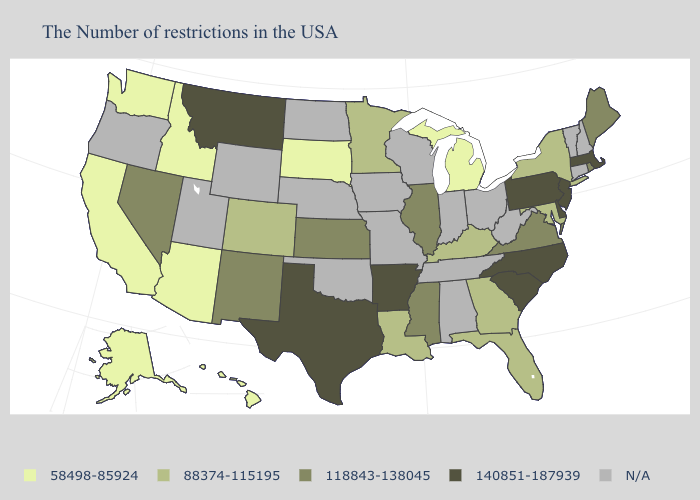What is the lowest value in the USA?
Be succinct. 58498-85924. Name the states that have a value in the range 140851-187939?
Give a very brief answer. Massachusetts, New Jersey, Delaware, Pennsylvania, North Carolina, South Carolina, Arkansas, Texas, Montana. Name the states that have a value in the range N/A?
Keep it brief. New Hampshire, Vermont, Connecticut, West Virginia, Ohio, Indiana, Alabama, Tennessee, Wisconsin, Missouri, Iowa, Nebraska, Oklahoma, North Dakota, Wyoming, Utah, Oregon. What is the value of North Carolina?
Short answer required. 140851-187939. Among the states that border Connecticut , which have the highest value?
Concise answer only. Massachusetts. What is the value of Maine?
Write a very short answer. 118843-138045. What is the value of Illinois?
Be succinct. 118843-138045. What is the lowest value in states that border South Carolina?
Answer briefly. 88374-115195. What is the value of Ohio?
Short answer required. N/A. Name the states that have a value in the range 140851-187939?
Concise answer only. Massachusetts, New Jersey, Delaware, Pennsylvania, North Carolina, South Carolina, Arkansas, Texas, Montana. Does the first symbol in the legend represent the smallest category?
Concise answer only. Yes. Does the map have missing data?
Quick response, please. Yes. Does South Dakota have the lowest value in the MidWest?
Give a very brief answer. Yes. Name the states that have a value in the range N/A?
Write a very short answer. New Hampshire, Vermont, Connecticut, West Virginia, Ohio, Indiana, Alabama, Tennessee, Wisconsin, Missouri, Iowa, Nebraska, Oklahoma, North Dakota, Wyoming, Utah, Oregon. 